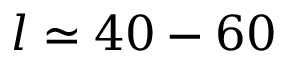Convert formula to latex. <formula><loc_0><loc_0><loc_500><loc_500>l \simeq 4 0 - 6 0</formula> 